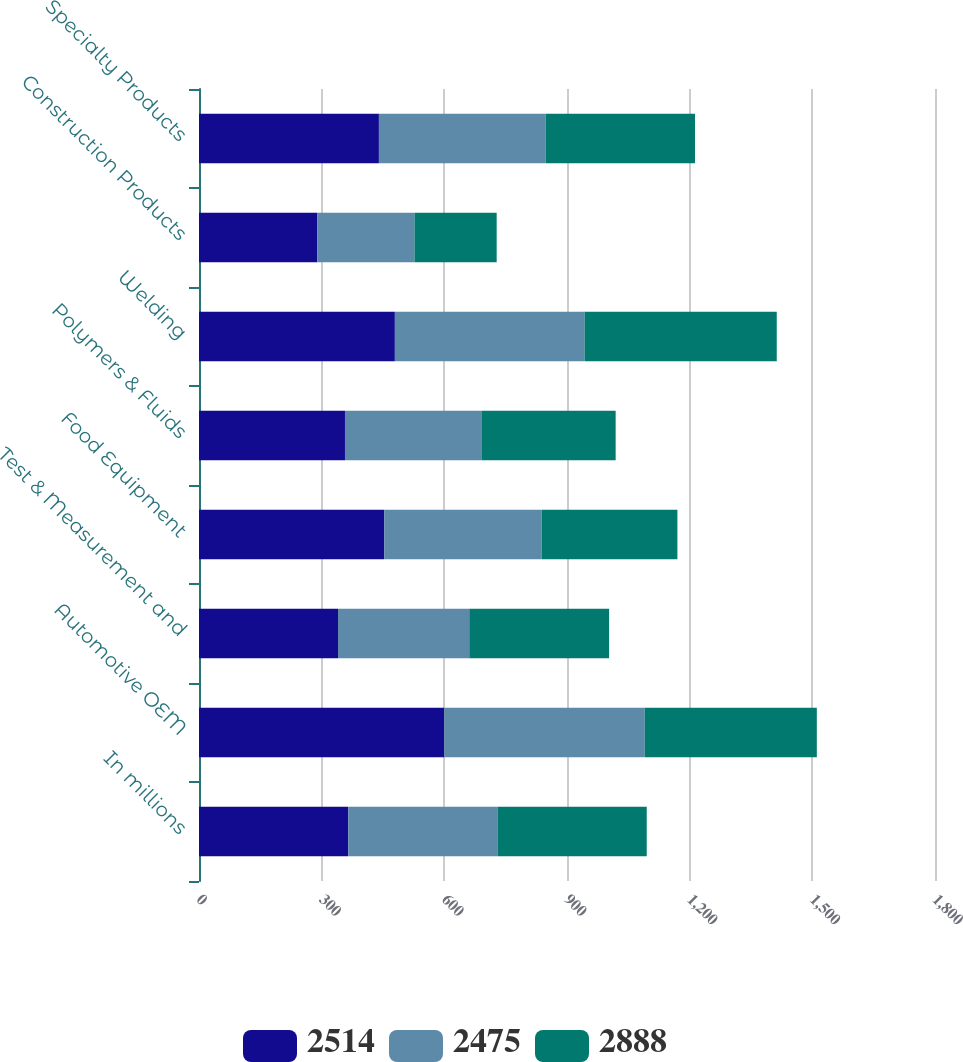Convert chart to OTSL. <chart><loc_0><loc_0><loc_500><loc_500><stacked_bar_chart><ecel><fcel>In millions<fcel>Automotive OEM<fcel>Test & Measurement and<fcel>Food Equipment<fcel>Polymers & Fluids<fcel>Welding<fcel>Construction Products<fcel>Specialty Products<nl><fcel>2514<fcel>365<fcel>600<fcel>340<fcel>453<fcel>357<fcel>479<fcel>289<fcel>440<nl><fcel>2475<fcel>365<fcel>490<fcel>321<fcel>385<fcel>335<fcel>464<fcel>238<fcel>408<nl><fcel>2888<fcel>365<fcel>421<fcel>342<fcel>332<fcel>327<fcel>470<fcel>201<fcel>365<nl></chart> 